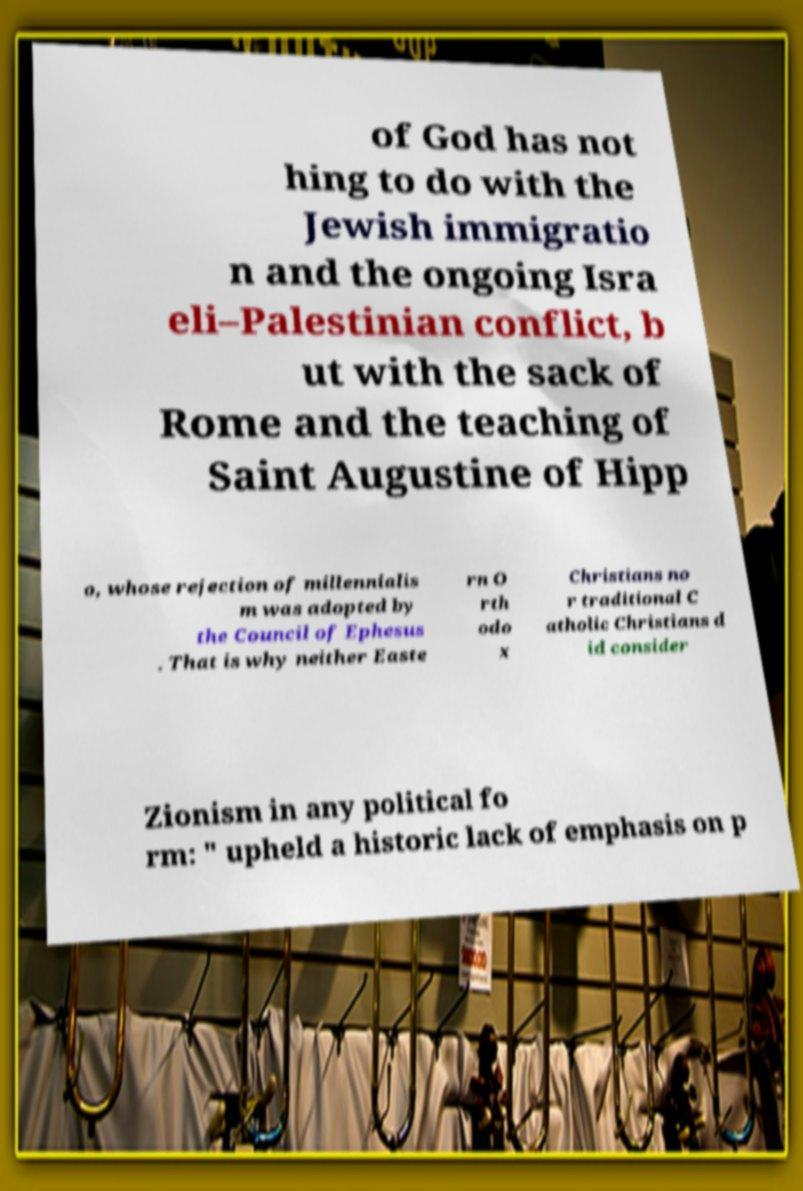Can you read and provide the text displayed in the image?This photo seems to have some interesting text. Can you extract and type it out for me? of God has not hing to do with the Jewish immigratio n and the ongoing Isra eli–Palestinian conflict, b ut with the sack of Rome and the teaching of Saint Augustine of Hipp o, whose rejection of millennialis m was adopted by the Council of Ephesus . That is why neither Easte rn O rth odo x Christians no r traditional C atholic Christians d id consider Zionism in any political fo rm: " upheld a historic lack of emphasis on p 